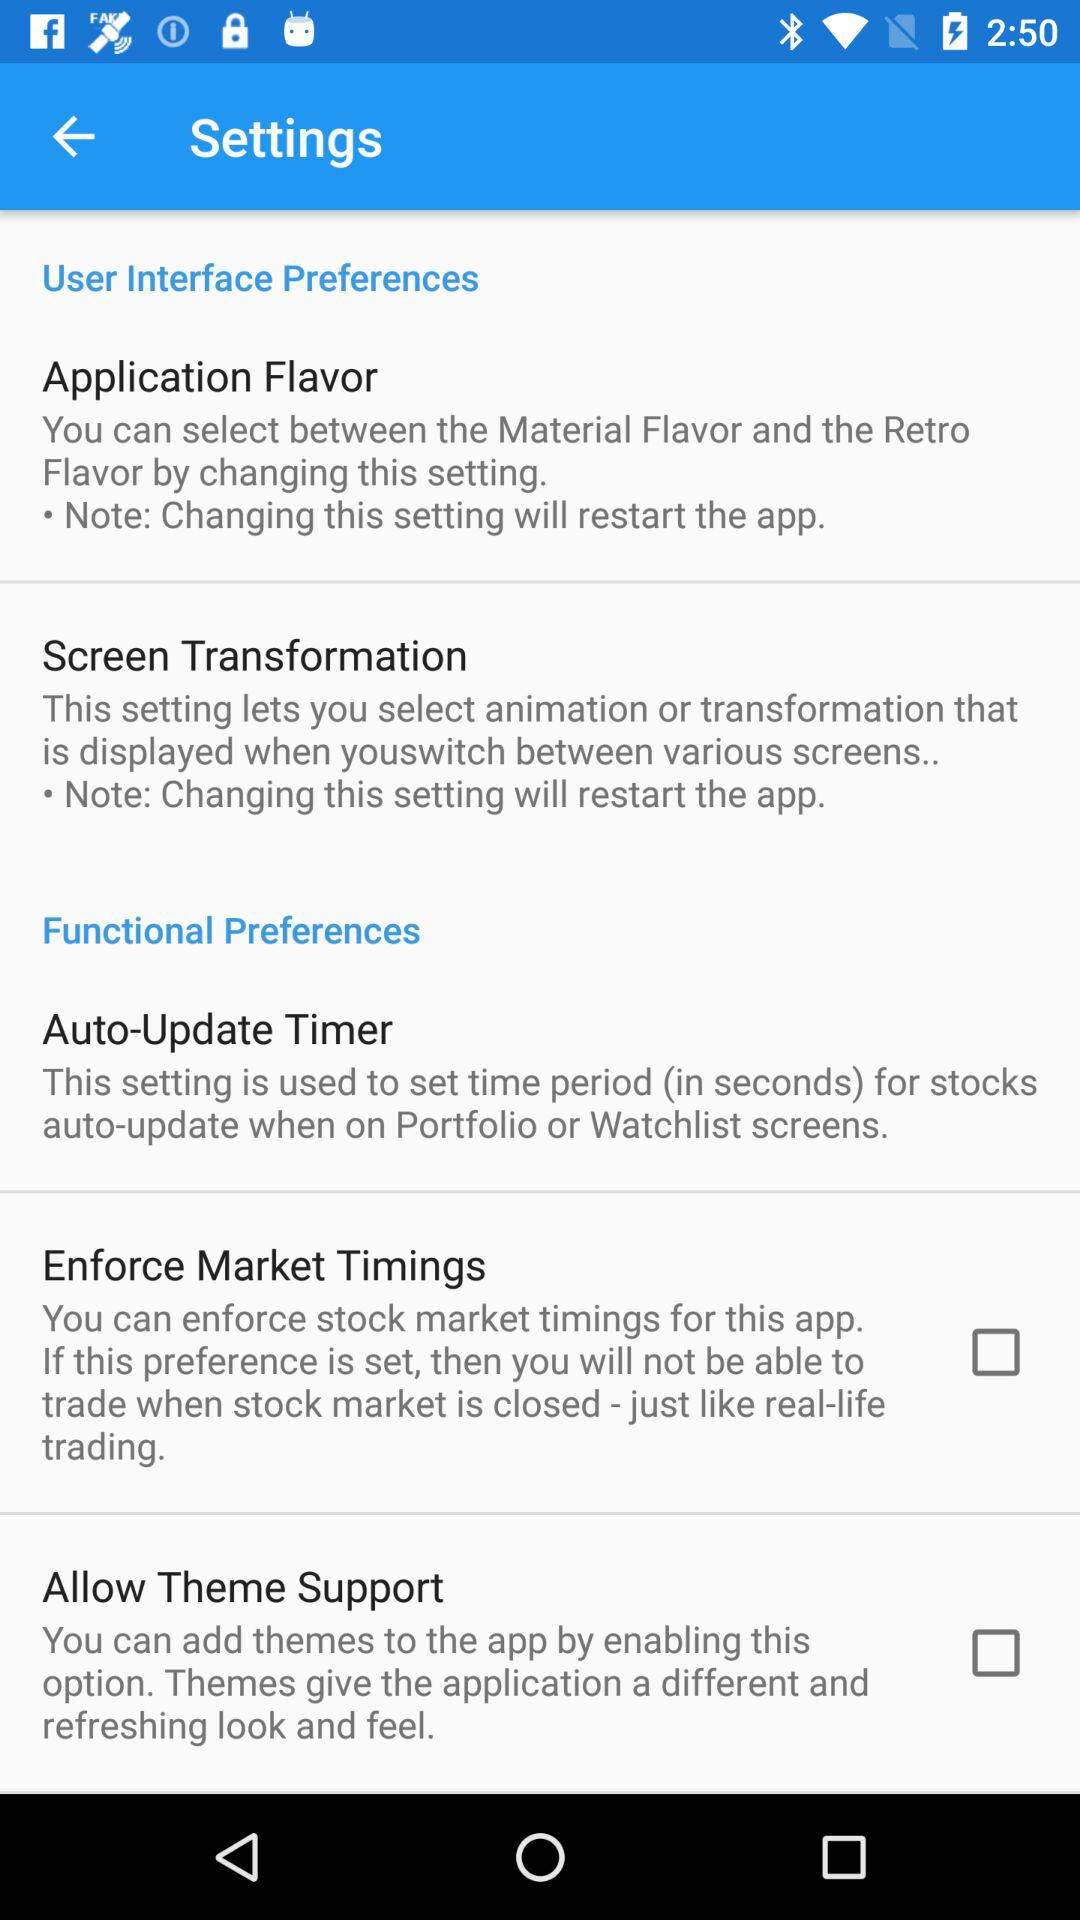What is the status of the "Allow Theme Support"? The status is "off". 